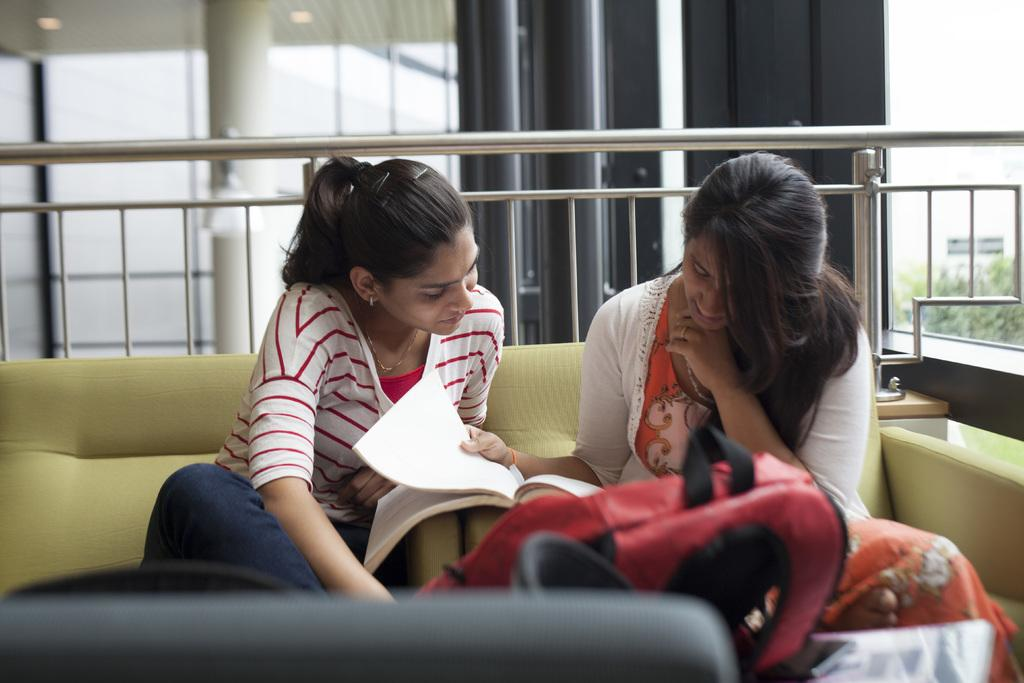How many people are in the image? There are two persons in the image. What are the persons wearing? The persons are wearing clothes. Where are the persons sitting? The persons are sitting on a sofa. What can be seen in the middle of the image? There are pillars and grills in the middle of the image. What object is located at the bottom of the image? There is a bag at the bottom of the image. What type of coal is being used to fuel the grills in the image? There is no coal present in the image; it features grills but does not specify the fuel source. What color are the berries that the persons are eating in the image? There are no berries present in the image, so it is not possible to determine their color. 